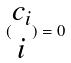Convert formula to latex. <formula><loc_0><loc_0><loc_500><loc_500>( \begin{matrix} c _ { i } \\ i \end{matrix} ) = 0</formula> 